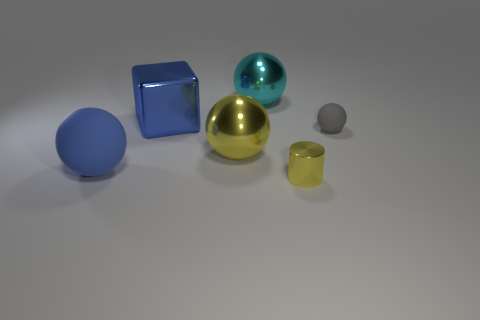What shape is the blue thing that is in front of the small gray ball?
Your response must be concise. Sphere. There is a object that is both to the left of the yellow shiny sphere and in front of the metallic block; what shape is it?
Give a very brief answer. Sphere. What number of gray things are small matte things or small metal cubes?
Give a very brief answer. 1. Is the color of the shiny ball that is right of the large yellow thing the same as the small matte ball?
Provide a succinct answer. No. How big is the metallic sphere in front of the big cyan metal thing on the left side of the gray ball?
Make the answer very short. Large. There is a cyan object that is the same size as the blue shiny cube; what material is it?
Offer a very short reply. Metal. What number of other things are the same size as the yellow ball?
Offer a very short reply. 3. What number of spheres are either big yellow shiny objects or yellow metallic things?
Make the answer very short. 1. Is there any other thing that has the same material as the yellow sphere?
Your answer should be very brief. Yes. There is a big ball behind the rubber thing to the right of the blue object in front of the gray rubber sphere; what is it made of?
Offer a very short reply. Metal. 